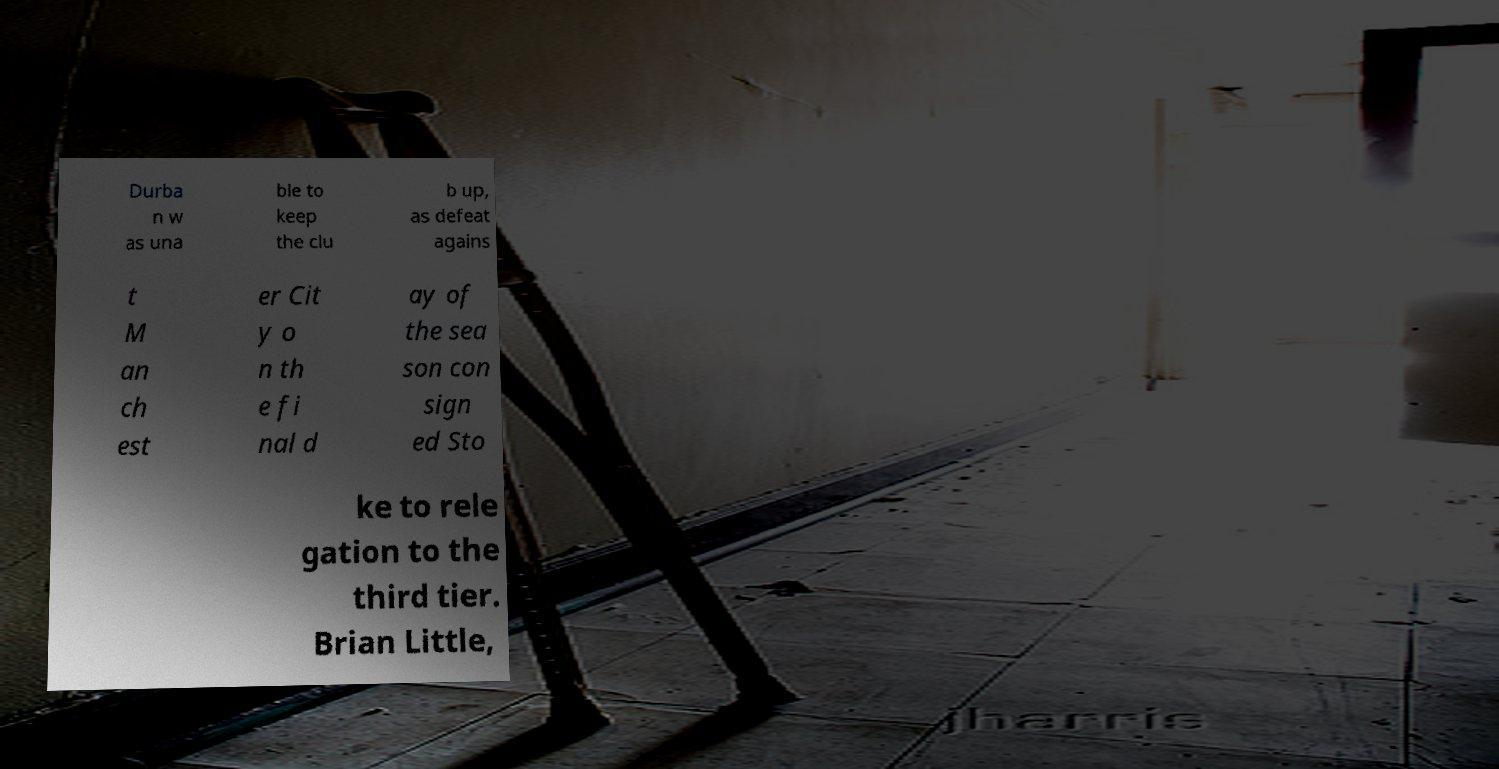Can you read and provide the text displayed in the image?This photo seems to have some interesting text. Can you extract and type it out for me? Durba n w as una ble to keep the clu b up, as defeat agains t M an ch est er Cit y o n th e fi nal d ay of the sea son con sign ed Sto ke to rele gation to the third tier. Brian Little, 